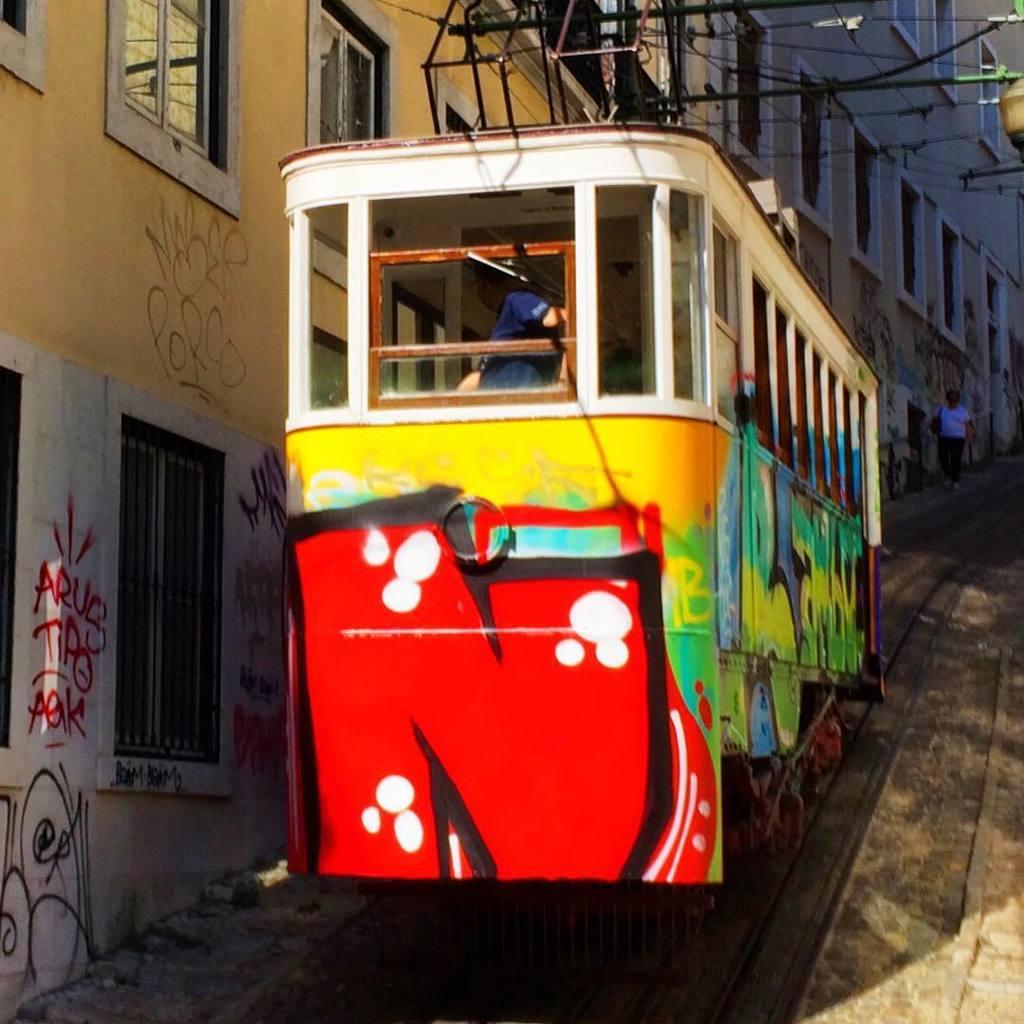In one or two sentences, can you explain what this image depicts? In this picture we can see a person in the tram and behind the tram there is a person walking. On the left side of the team there is a wall with windows and some scribblings. At the top there are cables. 